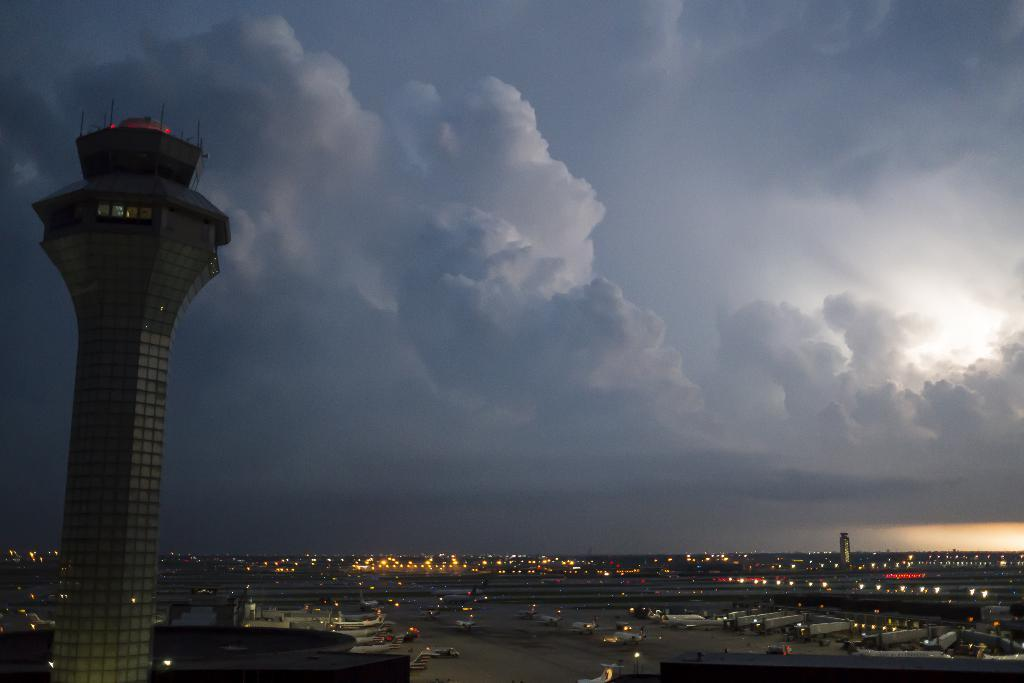What structures are present in the image? There are towers in the image. What else can be seen in the image besides the towers? There are lights and aircraft on the ground in the image. How would you describe the color of the sky in the image? The sky is blue and white in color. What type of sail can be seen on the aircraft in the image? There are no sails present on the aircraft in the image, as they are not sailing vessels. Is there any oatmeal visible in the image? There is no oatmeal present in the image. 